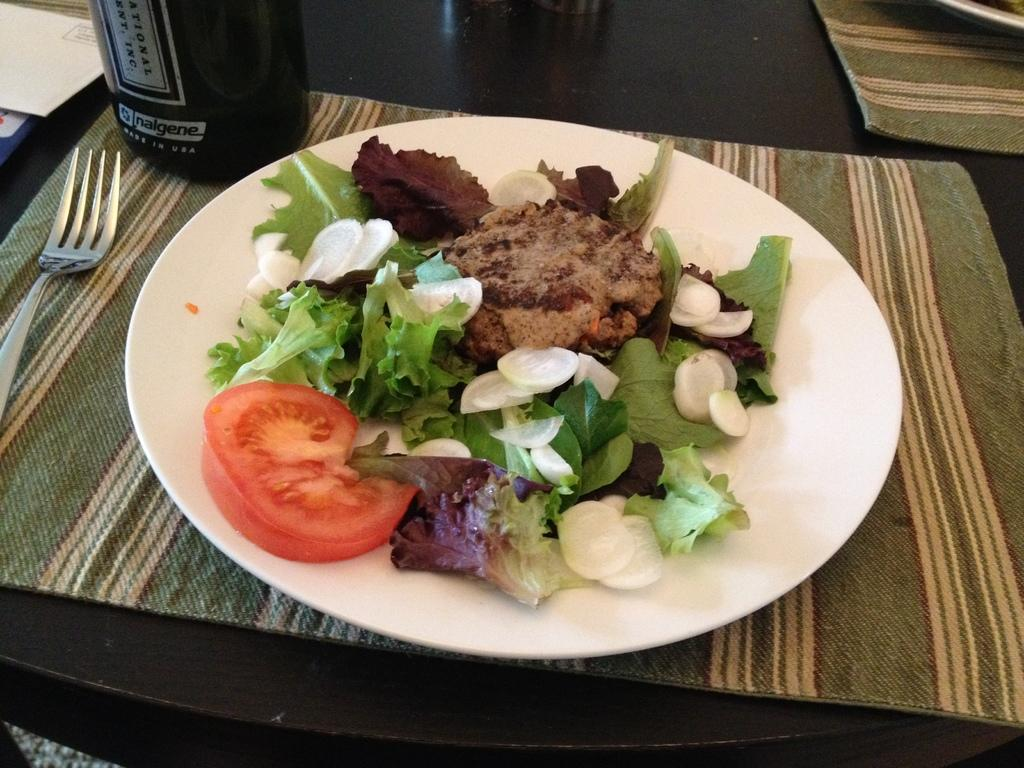What is on the plate in the image? There is food in the plate. What utensil is placed near the plate? A fork is present beside the plate. What can be seen on the table in the image? There is a bottle on the table, as well as other unspecified items. What type of square books can be seen reciting a verse in the image? There are no books or verses present in the image; it features a plate of food, a fork, a bottle, and other unspecified items on a table. 